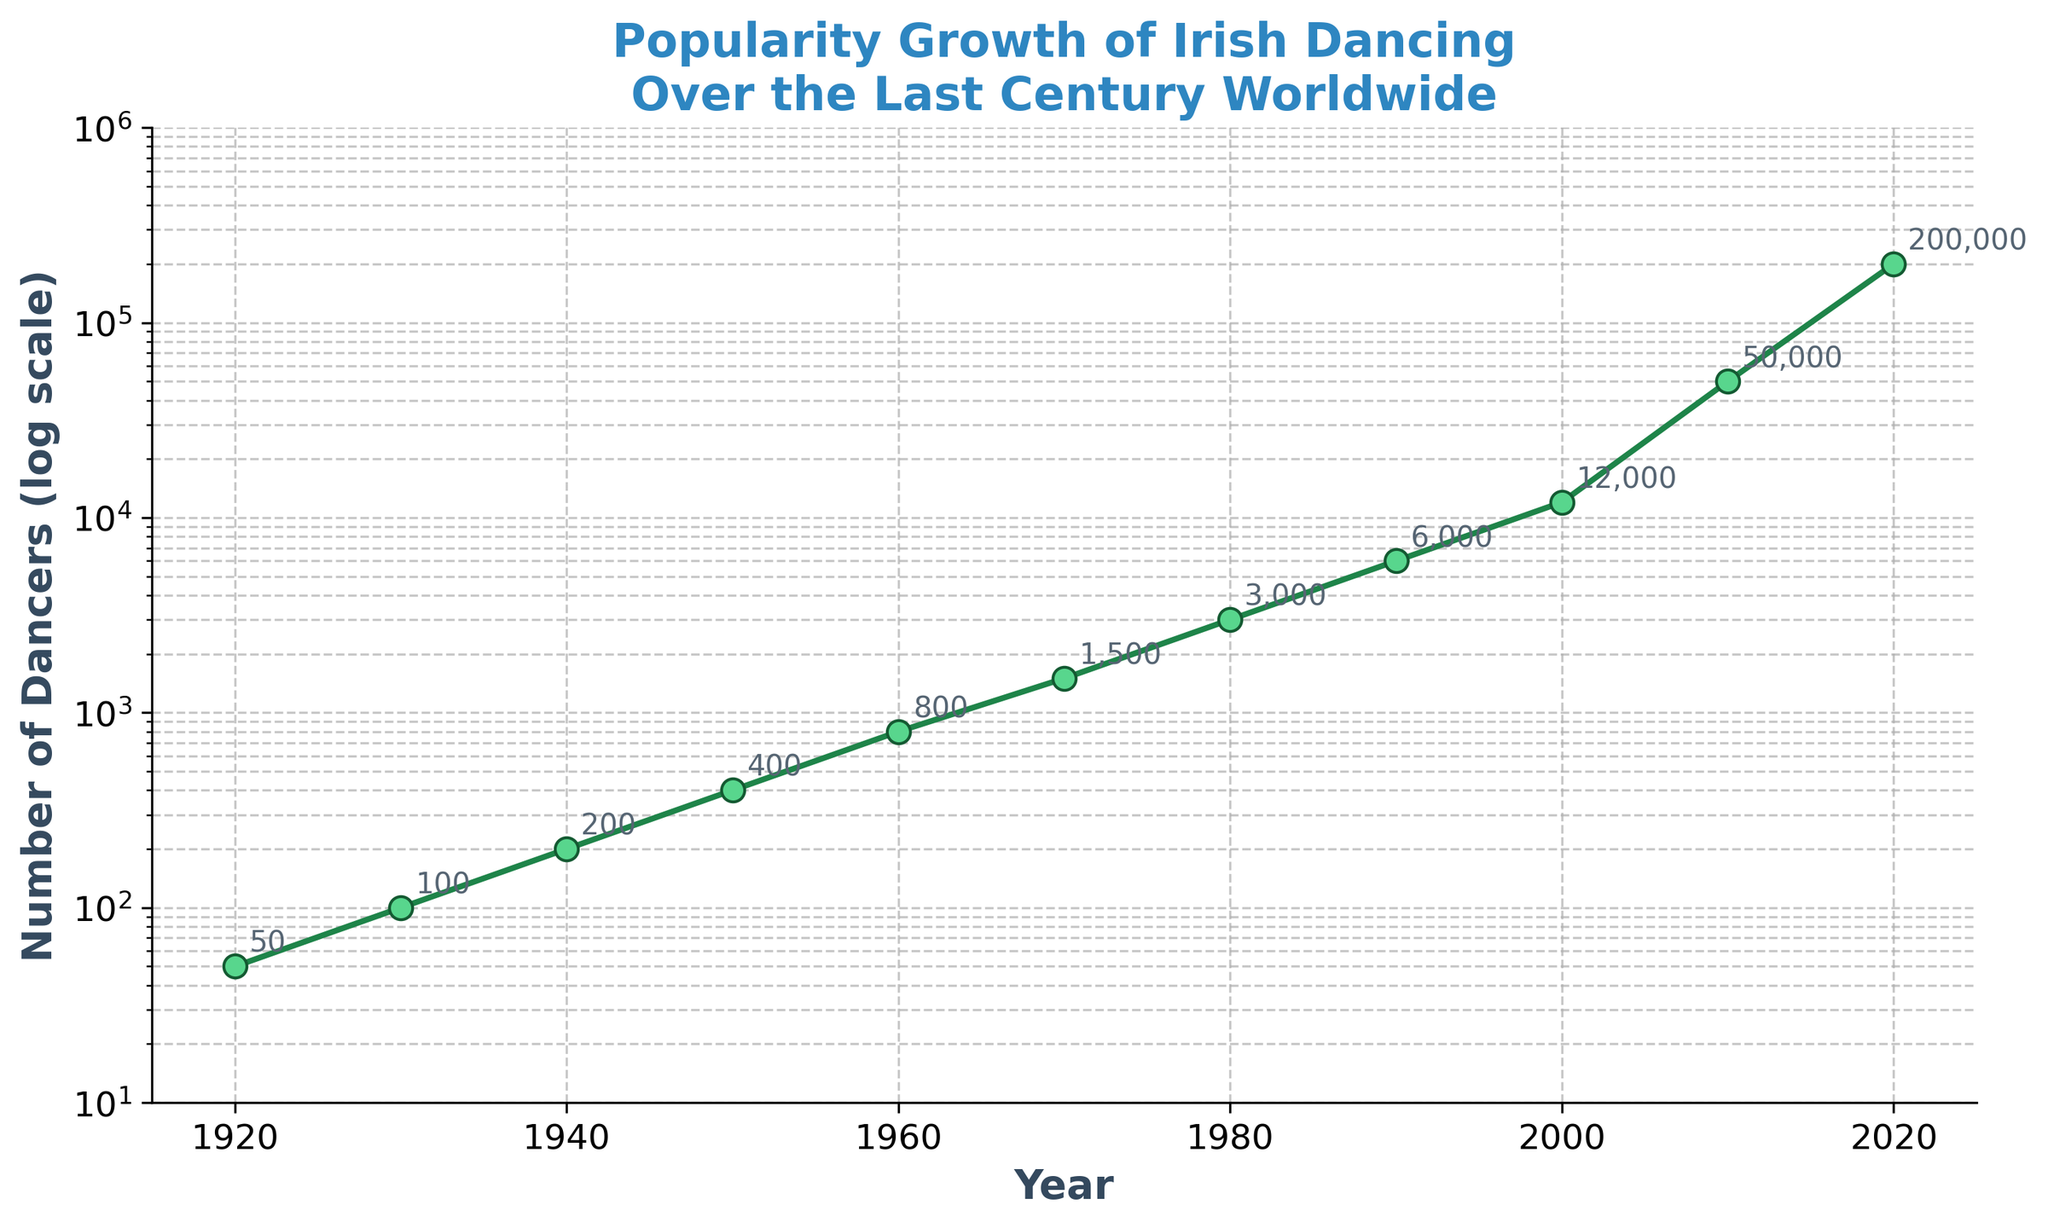What is the title of the figure? The title is typically placed at the top of the figure. In this case, it is clearly labeled.
Answer: Popularity Growth of Irish Dancing Over the Last Century Worldwide What is the value for the number of dancers in 2020? You can identify the year 2020 along the x-axis and trace it upward to the corresponding point on the line, which is marked with the value.
Answer: 200,000 By how much did the number of dancers increase from 1970 to 1980? Find the number of dancers for the years 1970 and 1980 along the line plot, then subtract the 1970 value from the 1980 value.
Answer: 1,500 During which decade did the number of dancers grow the most? Look at the plot and identify the decade with the steepest increase in the number of dancers.
Answer: 2000-2010 Which year had the least number of dancers, and what was the value? Since the plot is on a logarithmic scale, the lowest point on the y-axis represents the minimum value. Trace this point to its corresponding year on the x-axis.
Answer: 1920, 50 What is the relationship seen in the log scale between the years and the number of dancers? The logarithmic scale compresses large ranges of data. The general trend of the line shows an exponential increase in the number of dancers over time.
Answer: Exponential Increase How many times did the number of dancers double between 1920 and 1960? Identify the doubling points: 1920 to 1930 (50 to 100), 1930 to 1940 (100 to 200), 1940 to 1950 (200 to 400), and 1950 to 1960 (400 to 800). Count these intervals.
Answer: 4 Compare the growth rate between the decades 1940-1950 and 1980-1990. Which was higher? Observe the steepness of the line for each decade. The speedier rise between two points on the log scale indicates a higher growth rate.
Answer: 1980-1990 What average number of dancers was there in the year 2000 and 2010? In the year 2000, there were 12,000 dancers and in the year 2010, there were 50,000. Add the two numbers and divide by two to get the average.
Answer: 31,000 